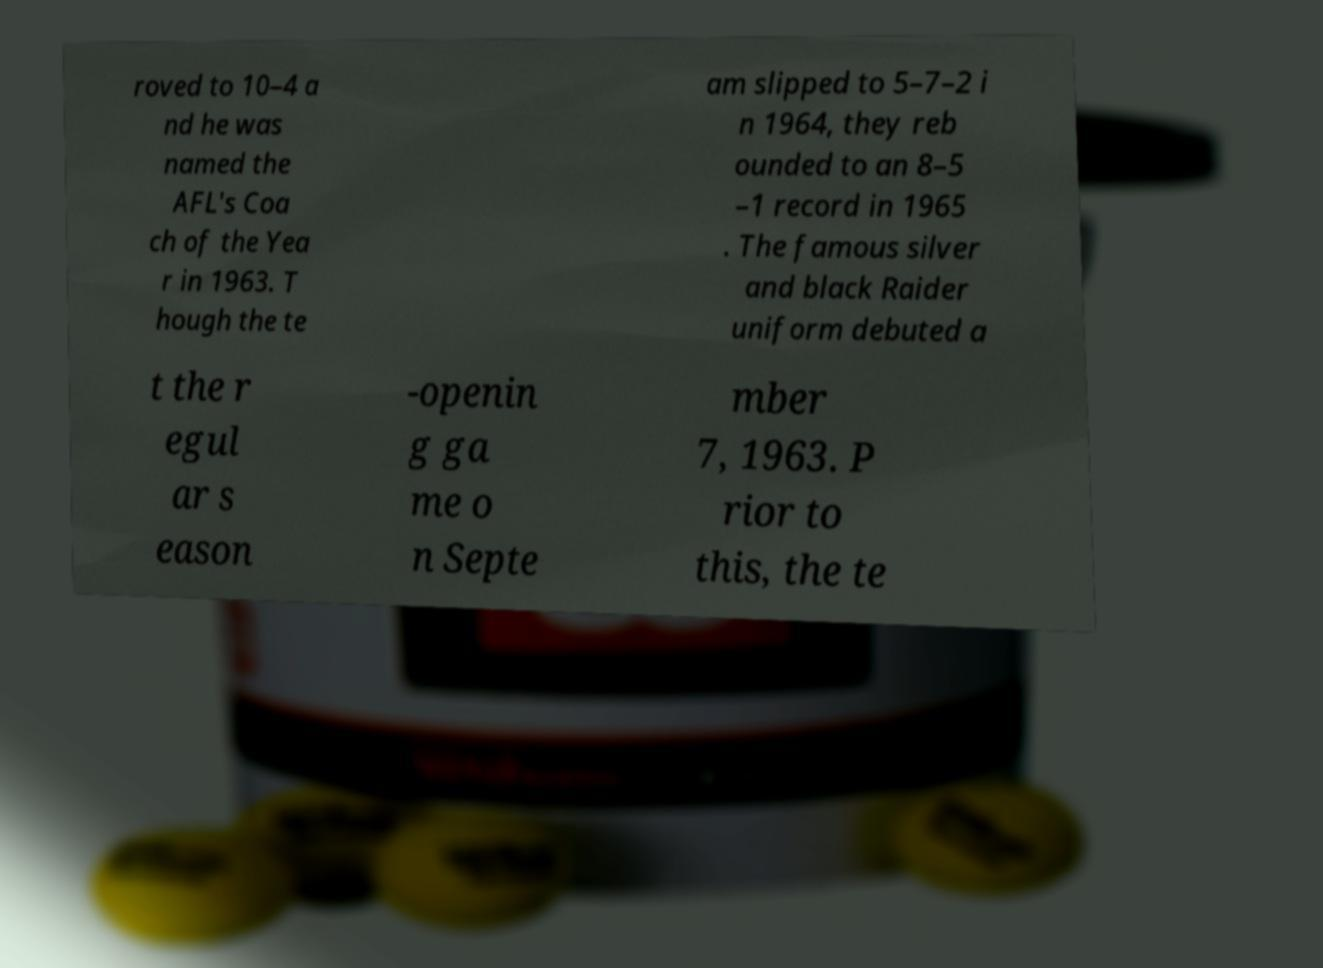Please identify and transcribe the text found in this image. roved to 10–4 a nd he was named the AFL's Coa ch of the Yea r in 1963. T hough the te am slipped to 5–7–2 i n 1964, they reb ounded to an 8–5 –1 record in 1965 . The famous silver and black Raider uniform debuted a t the r egul ar s eason -openin g ga me o n Septe mber 7, 1963. P rior to this, the te 